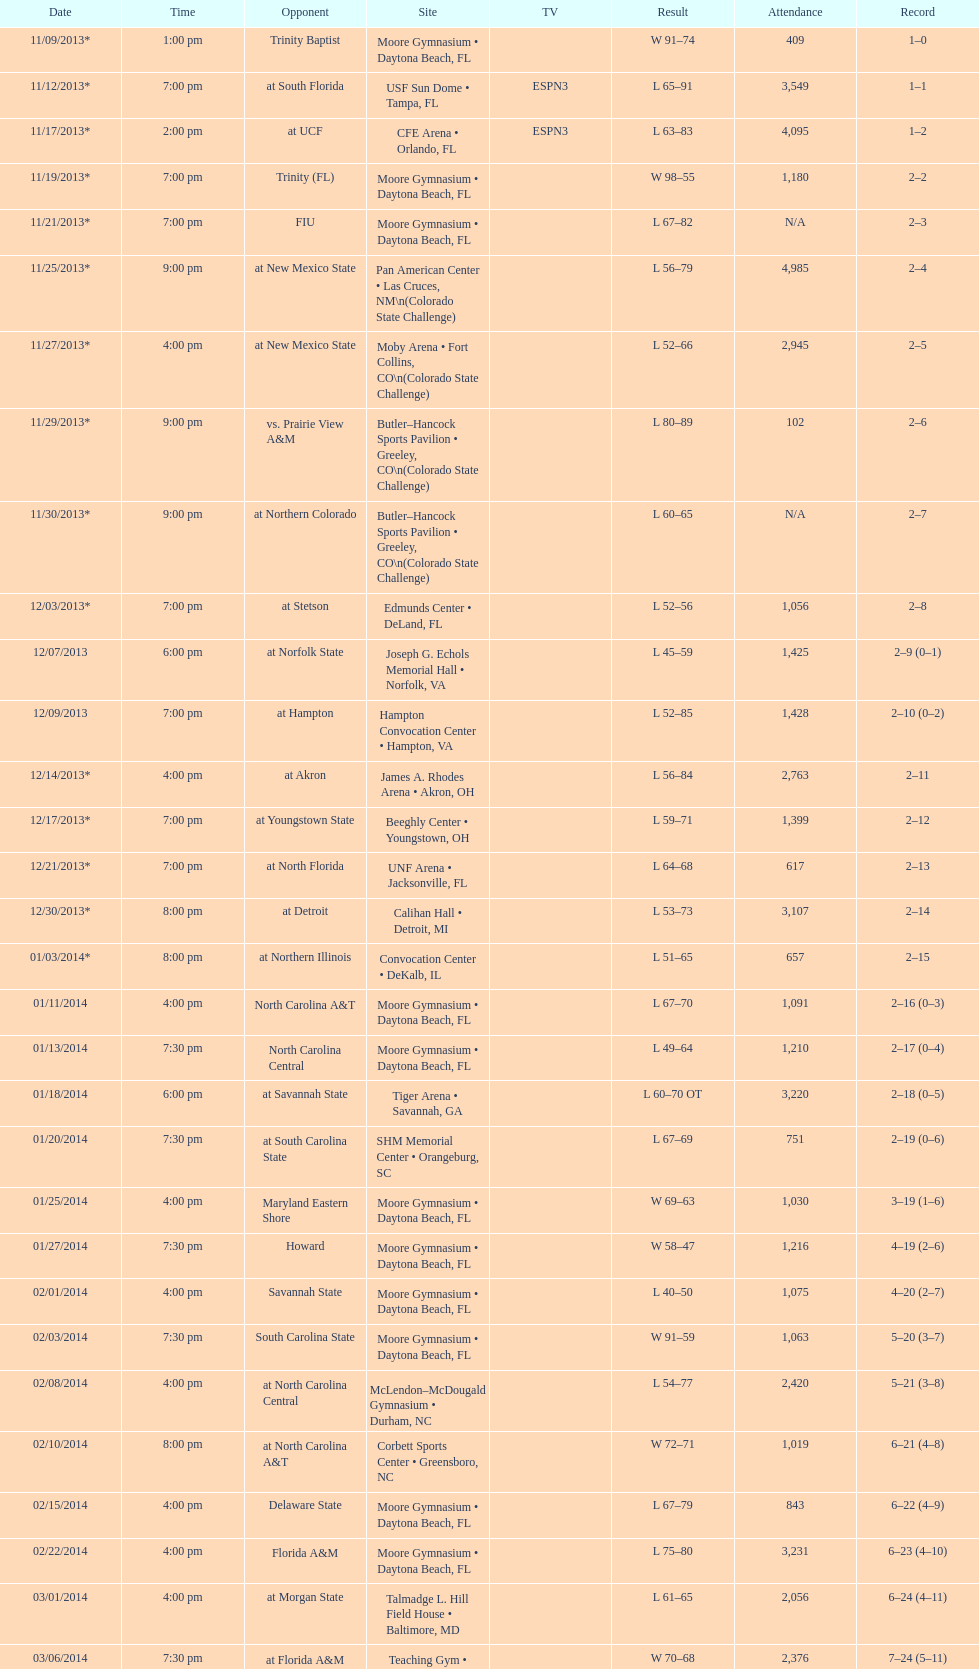How many teams had up to 1,000 attendees? 6. 